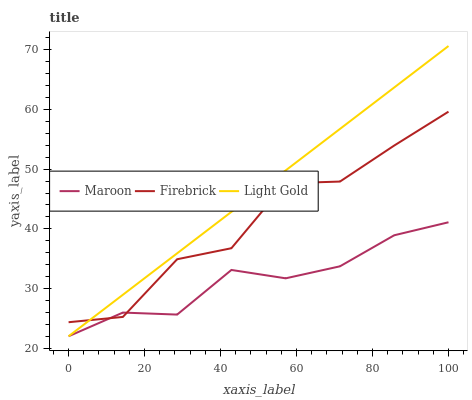Does Maroon have the minimum area under the curve?
Answer yes or no. Yes. Does Light Gold have the maximum area under the curve?
Answer yes or no. Yes. Does Light Gold have the minimum area under the curve?
Answer yes or no. No. Does Maroon have the maximum area under the curve?
Answer yes or no. No. Is Light Gold the smoothest?
Answer yes or no. Yes. Is Firebrick the roughest?
Answer yes or no. Yes. Is Maroon the smoothest?
Answer yes or no. No. Is Maroon the roughest?
Answer yes or no. No. Does Light Gold have the lowest value?
Answer yes or no. Yes. Does Light Gold have the highest value?
Answer yes or no. Yes. Does Maroon have the highest value?
Answer yes or no. No. Does Maroon intersect Firebrick?
Answer yes or no. Yes. Is Maroon less than Firebrick?
Answer yes or no. No. Is Maroon greater than Firebrick?
Answer yes or no. No. 